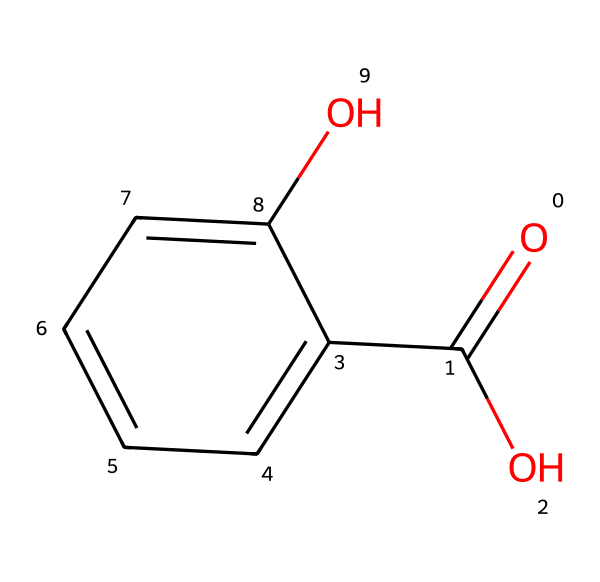How many carbon atoms are in salicylic acid? By analyzing the SMILES representation, we observe the presence of six 'C' symbols corresponding to carbon atoms. Each aromatic carbon in the benzene ring contributes to this count, along with the carbon in the carboxylic acid group.
Answer: six What type of functional group is present in salicylic acid? Looking at the structure, there are two functional groups: a hydroxyl group (–OH) and a carboxylic acid group (–COOH). The presence of the –COOH indicates that it is a carboxylic acid.
Answer: carboxylic acid How many hydrogen atoms are present in salicylic acid? The structure indicates six hydrogen atoms are attached to the carbon atoms. Counting the hydrogens bonded to the hydroxyl and the hydrogen in the carboxylic acid group leads to a total of six.
Answer: six Which part of salicylic acid contributes to its exfoliating properties? The presence of the hydroxyl group (–OH) on the aromatic ring structure allows for the exfoliating action, as it facilitates the shedding of dead skin cells.
Answer: hydroxyl group Is salicylic acid polar or nonpolar? The chemical structure includes polar functional groups like hydroxyl and carboxylic acid, which makes the entire molecule polar due to their ability to form hydrogen bonds with water.
Answer: polar What is the maximum number of carbon atoms in the aromatic ring of salicylic acid? The structure shows that the aromatic ring consists of six carbon atoms, which is the maximum number for a typical benzene derivative.
Answer: six What is the primary role of salicylic acid in cosmetic formulations? Its main role in cosmetic formulations is as an exfoliating agent, due to its ability to penetrate pores and help with the removal of dead skin cells.
Answer: exfoliating agent 